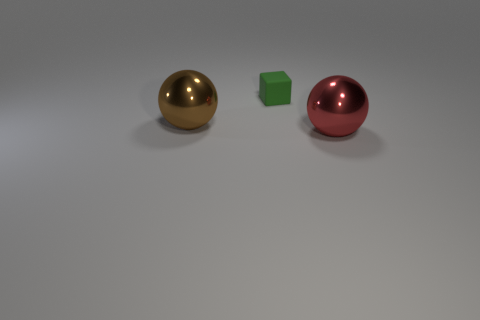There is a brown metal thing that is the same size as the red sphere; what shape is it? The object you're inquiring about appears brown due to the lighting, but it is actually a golden sphere, giving the impression of being made from a reflective metal. It shares the same spherical shape as the red one next to it. 